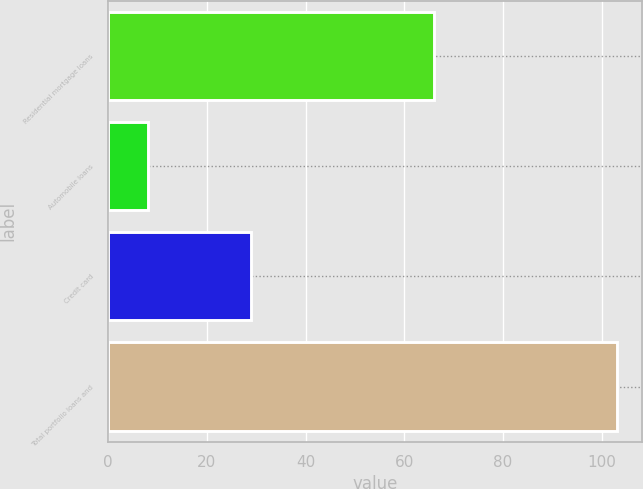Convert chart to OTSL. <chart><loc_0><loc_0><loc_500><loc_500><bar_chart><fcel>Residential mortgage loans<fcel>Automobile loans<fcel>Credit card<fcel>Total portfolio loans and<nl><fcel>66<fcel>8<fcel>29<fcel>103<nl></chart> 